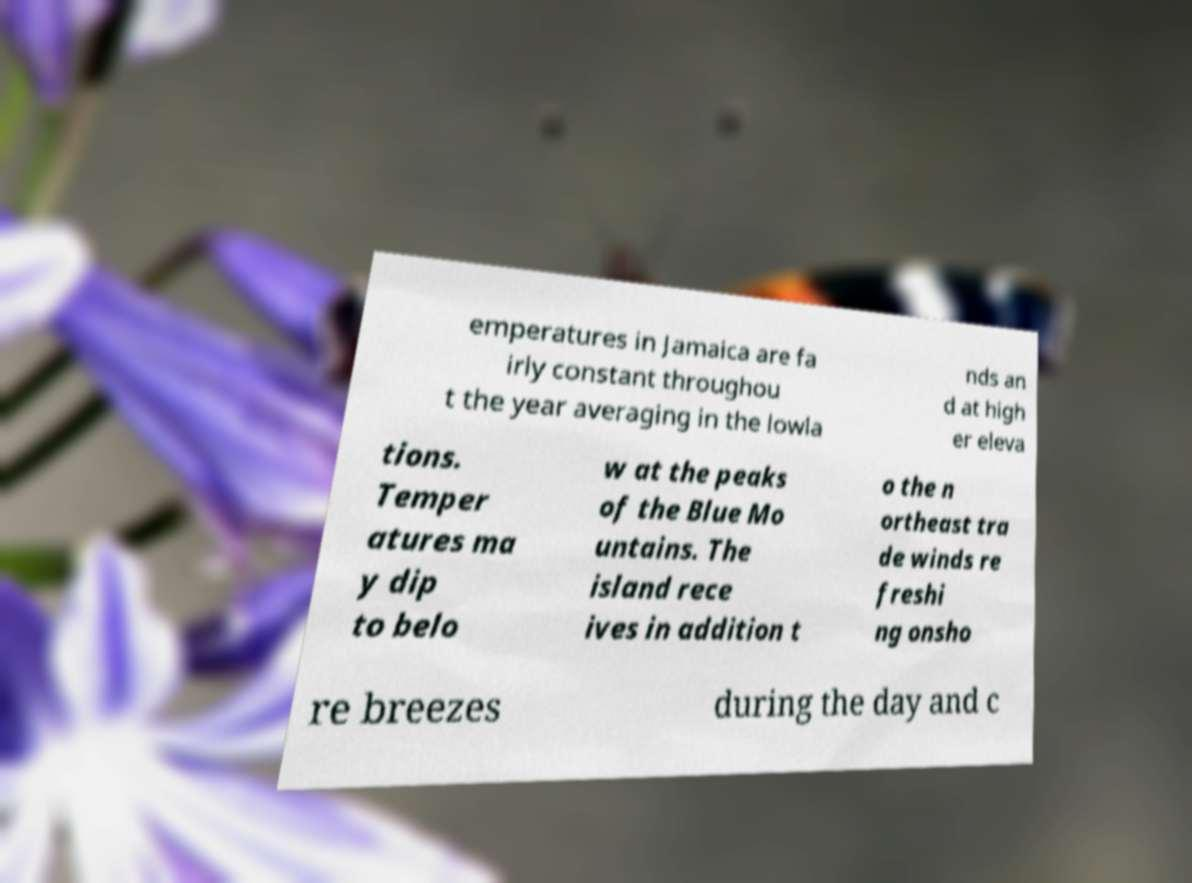What messages or text are displayed in this image? I need them in a readable, typed format. emperatures in Jamaica are fa irly constant throughou t the year averaging in the lowla nds an d at high er eleva tions. Temper atures ma y dip to belo w at the peaks of the Blue Mo untains. The island rece ives in addition t o the n ortheast tra de winds re freshi ng onsho re breezes during the day and c 